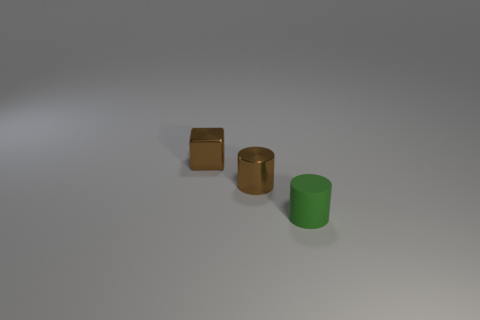What number of things are tiny rubber cylinders or small purple balls?
Keep it short and to the point. 1. What is the material of the object that is the same color as the metal block?
Your answer should be very brief. Metal. Are there any other small shiny things that have the same shape as the small green thing?
Give a very brief answer. Yes. What number of brown metal cylinders are behind the tiny matte cylinder?
Give a very brief answer. 1. What is the tiny thing that is in front of the small metal object that is right of the brown block made of?
Offer a terse response. Rubber. What is the material of the brown cube that is the same size as the green thing?
Your answer should be compact. Metal. Are there any purple cubes of the same size as the green matte cylinder?
Offer a terse response. No. There is a small cylinder that is left of the small green thing; what color is it?
Provide a short and direct response. Brown. Is there a small brown object behind the small brown object on the right side of the tiny shiny block?
Give a very brief answer. Yes. How many other objects are there of the same color as the matte cylinder?
Offer a very short reply. 0. 